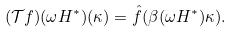<formula> <loc_0><loc_0><loc_500><loc_500>( \mathcal { T } f ) ( \omega H ^ { * } ) ( \kappa ) = \hat { f } ( \beta ( \omega H ^ { * } ) \kappa ) .</formula> 